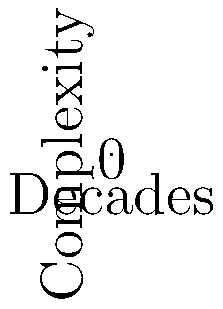Based on the graph depicting the evolution of rock album cover art complexity over decades, which decade shows the highest overall complexity and variability in design? To determine the decade with the highest overall complexity and variability in rock album cover art design, let's analyze the graph step-by-step:

1. The graph shows four curves, each representing a decade from the 1960s to the 1990s.
2. The y-axis represents complexity, with higher values indicating more complex designs.
3. The variability is shown by the amplitude of the curves' oscillations.

Analyzing each decade:
1960s (Blue line): Low complexity (average around 1) with moderate variability.
1970s (Red line): Higher complexity (average around 1.5) with increased variability.
1980s (Green line): Even higher complexity (average around 2) with slightly less variability than the 1970s.
1990s (Orange line): Highest complexity (average around 2.5) but with the least variability.

The 1970s show a significant increase in both complexity and variability compared to the 1960s. While the 1980s and 1990s continue to increase in overall complexity, their variability decreases.

Therefore, the 1970s demonstrate the best balance of high complexity and high variability in rock album cover art design.
Answer: 1970s 